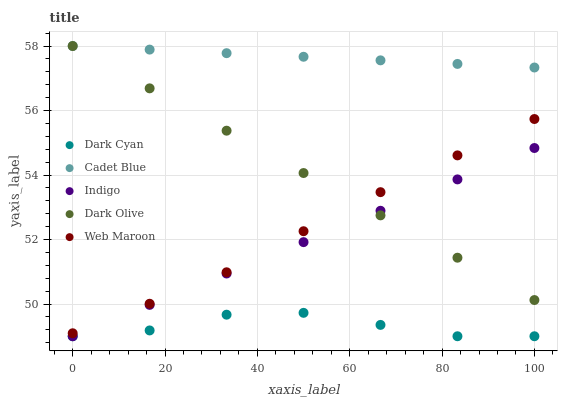Does Dark Cyan have the minimum area under the curve?
Answer yes or no. Yes. Does Cadet Blue have the maximum area under the curve?
Answer yes or no. Yes. Does Web Maroon have the minimum area under the curve?
Answer yes or no. No. Does Web Maroon have the maximum area under the curve?
Answer yes or no. No. Is Indigo the smoothest?
Answer yes or no. Yes. Is Dark Cyan the roughest?
Answer yes or no. Yes. Is Web Maroon the smoothest?
Answer yes or no. No. Is Web Maroon the roughest?
Answer yes or no. No. Does Dark Cyan have the lowest value?
Answer yes or no. Yes. Does Web Maroon have the lowest value?
Answer yes or no. No. Does Cadet Blue have the highest value?
Answer yes or no. Yes. Does Web Maroon have the highest value?
Answer yes or no. No. Is Web Maroon less than Cadet Blue?
Answer yes or no. Yes. Is Dark Olive greater than Dark Cyan?
Answer yes or no. Yes. Does Dark Olive intersect Web Maroon?
Answer yes or no. Yes. Is Dark Olive less than Web Maroon?
Answer yes or no. No. Is Dark Olive greater than Web Maroon?
Answer yes or no. No. Does Web Maroon intersect Cadet Blue?
Answer yes or no. No. 